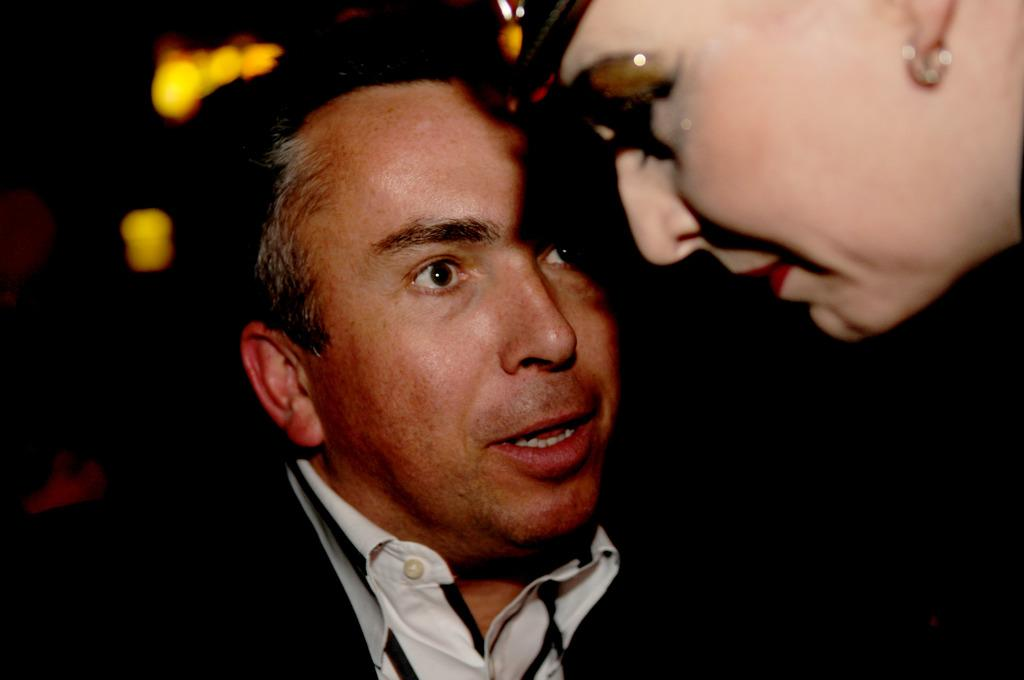Who is present in the image? There is a man in the image. What can be seen in the top right corner of the image? There is a person's face in the top right corner of the image. How would you describe the overall lighting in the image? The background of the image is dark, but there are lights visible in the background. What type of crate is being used to transport the alarm in the image? There is no crate or alarm present in the image. 